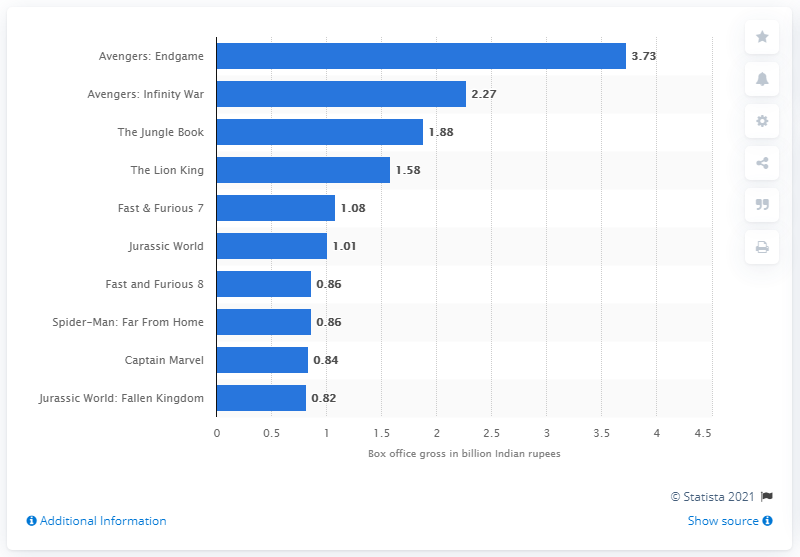Point out several critical features in this image. As of August 2020, "Avengers: Endgame" was the highest grossing movie in India. 